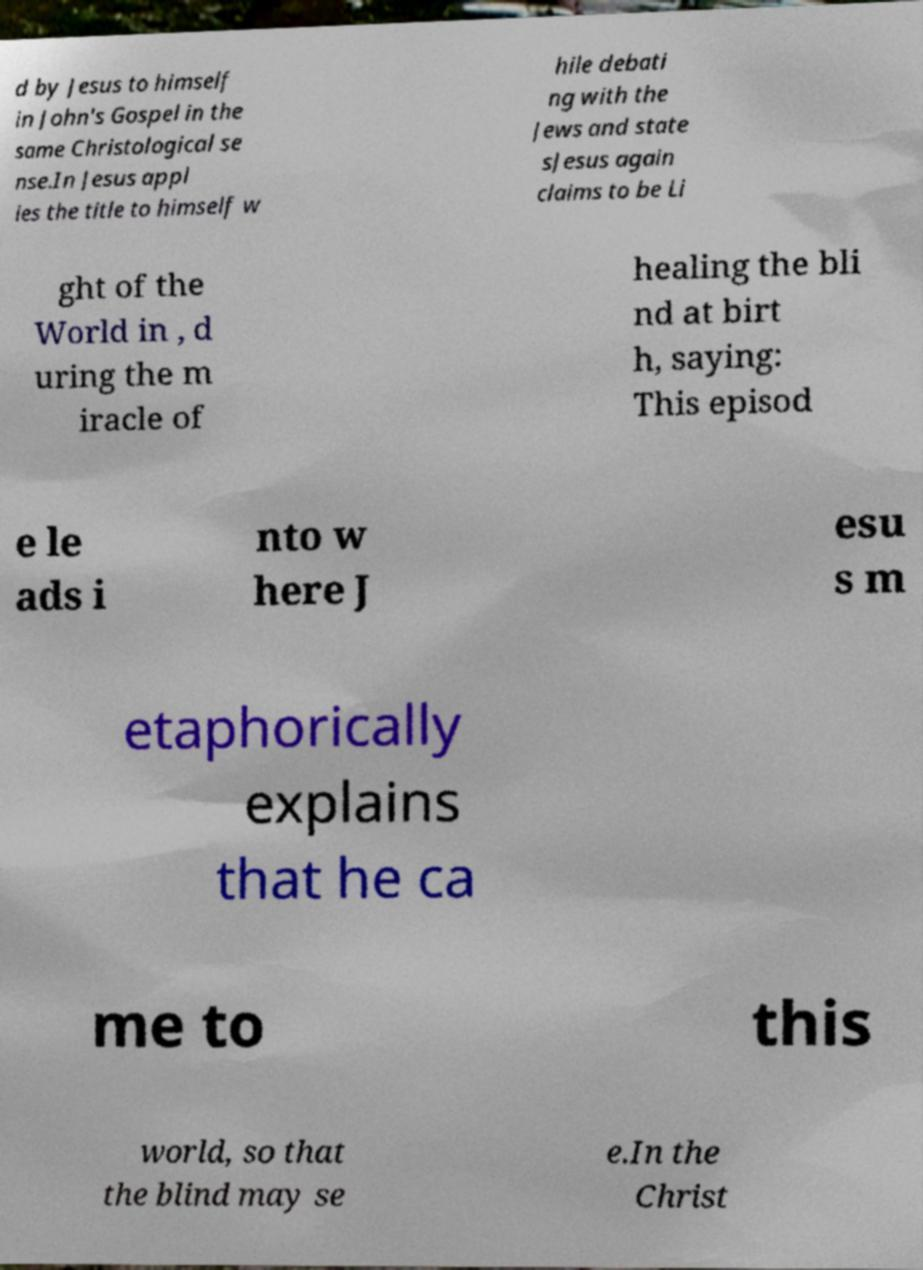Please identify and transcribe the text found in this image. d by Jesus to himself in John's Gospel in the same Christological se nse.In Jesus appl ies the title to himself w hile debati ng with the Jews and state sJesus again claims to be Li ght of the World in , d uring the m iracle of healing the bli nd at birt h, saying: This episod e le ads i nto w here J esu s m etaphorically explains that he ca me to this world, so that the blind may se e.In the Christ 